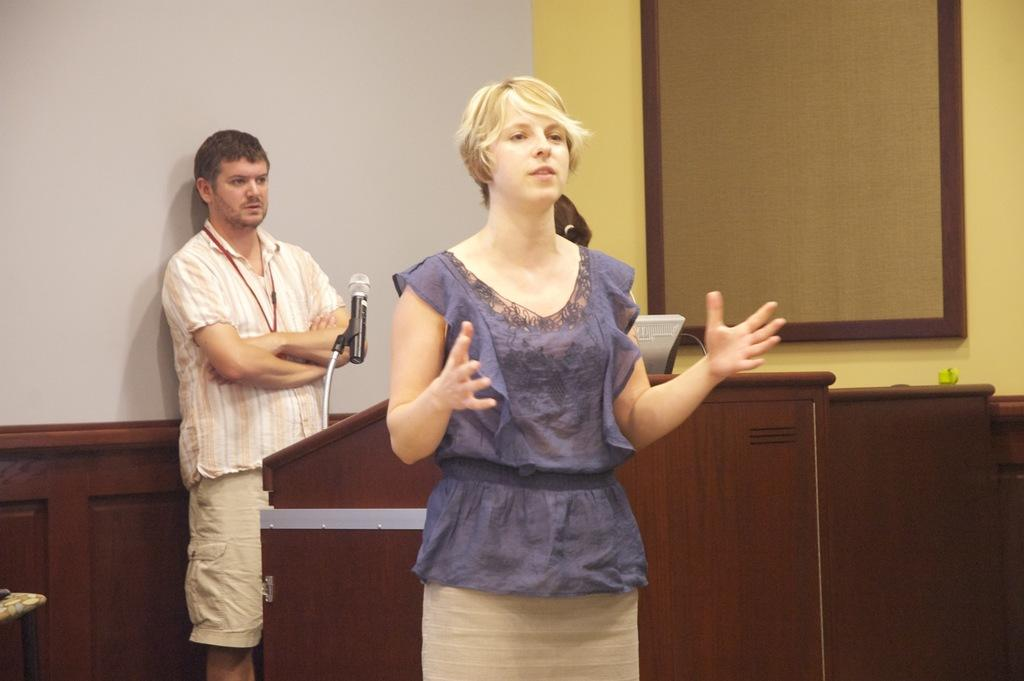How many people are in the image? There are two people in the image. What object can be seen in the image that might be used for public speaking? There is a podium in the image, which is often used for public speaking. What is on the podium? The podium has a mic on it. What is the color of the background in the image? The background of the image is white. What type of rail can be seen in the image? There is no rail present in the image. How does the achiever drop their notes in the image? There is no achiever or dropped notes present in the image. 